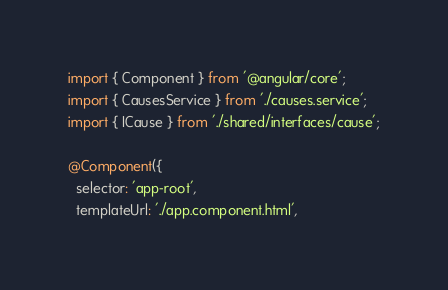Convert code to text. <code><loc_0><loc_0><loc_500><loc_500><_TypeScript_>import { Component } from '@angular/core';
import { CausesService } from './causes.service';
import { ICause } from './shared/interfaces/cause';

@Component({
  selector: 'app-root',
  templateUrl: './app.component.html',</code> 